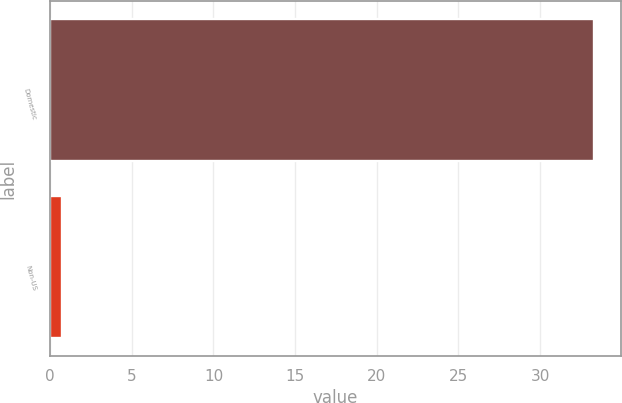Convert chart to OTSL. <chart><loc_0><loc_0><loc_500><loc_500><bar_chart><fcel>Domestic<fcel>Non-US<nl><fcel>33.3<fcel>0.7<nl></chart> 